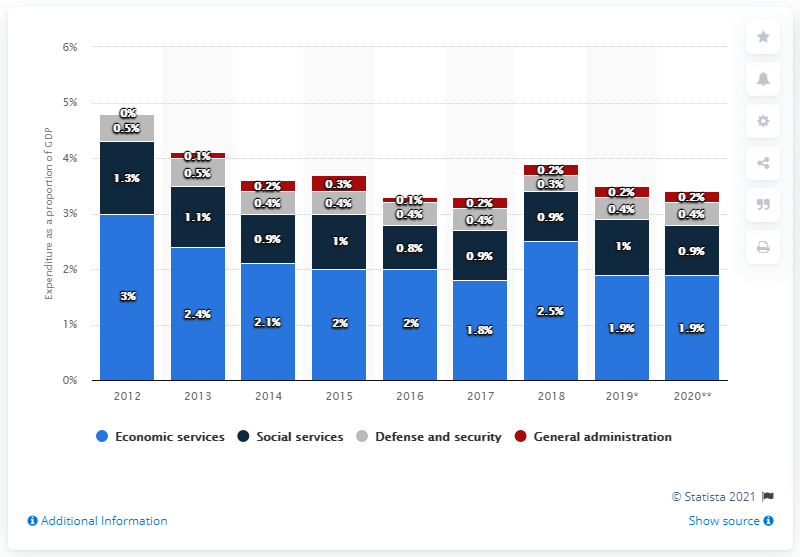Mention a couple of crucial points in this snapshot. In 2019, Malaysia's gross domestic product (GDP) spent on economic services was 1.9%. 